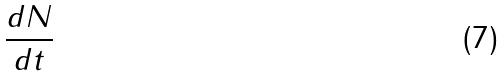Convert formula to latex. <formula><loc_0><loc_0><loc_500><loc_500>\frac { d N } { d t }</formula> 